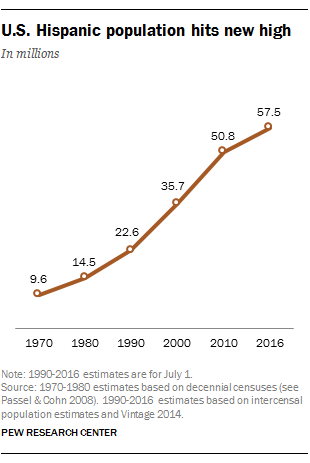Outline some significant characteristics in this image. The average population from 2000 to 2016 was 48. The population was lowest in the year 1970. 